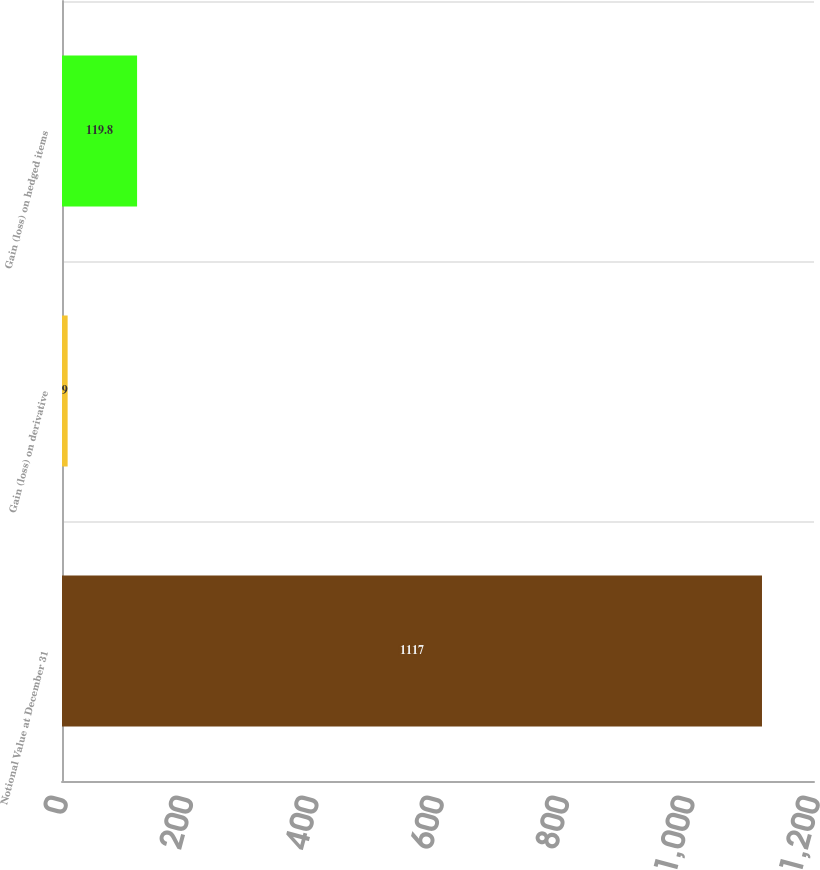<chart> <loc_0><loc_0><loc_500><loc_500><bar_chart><fcel>Notional Value at December 31<fcel>Gain (loss) on derivative<fcel>Gain (loss) on hedged items<nl><fcel>1117<fcel>9<fcel>119.8<nl></chart> 